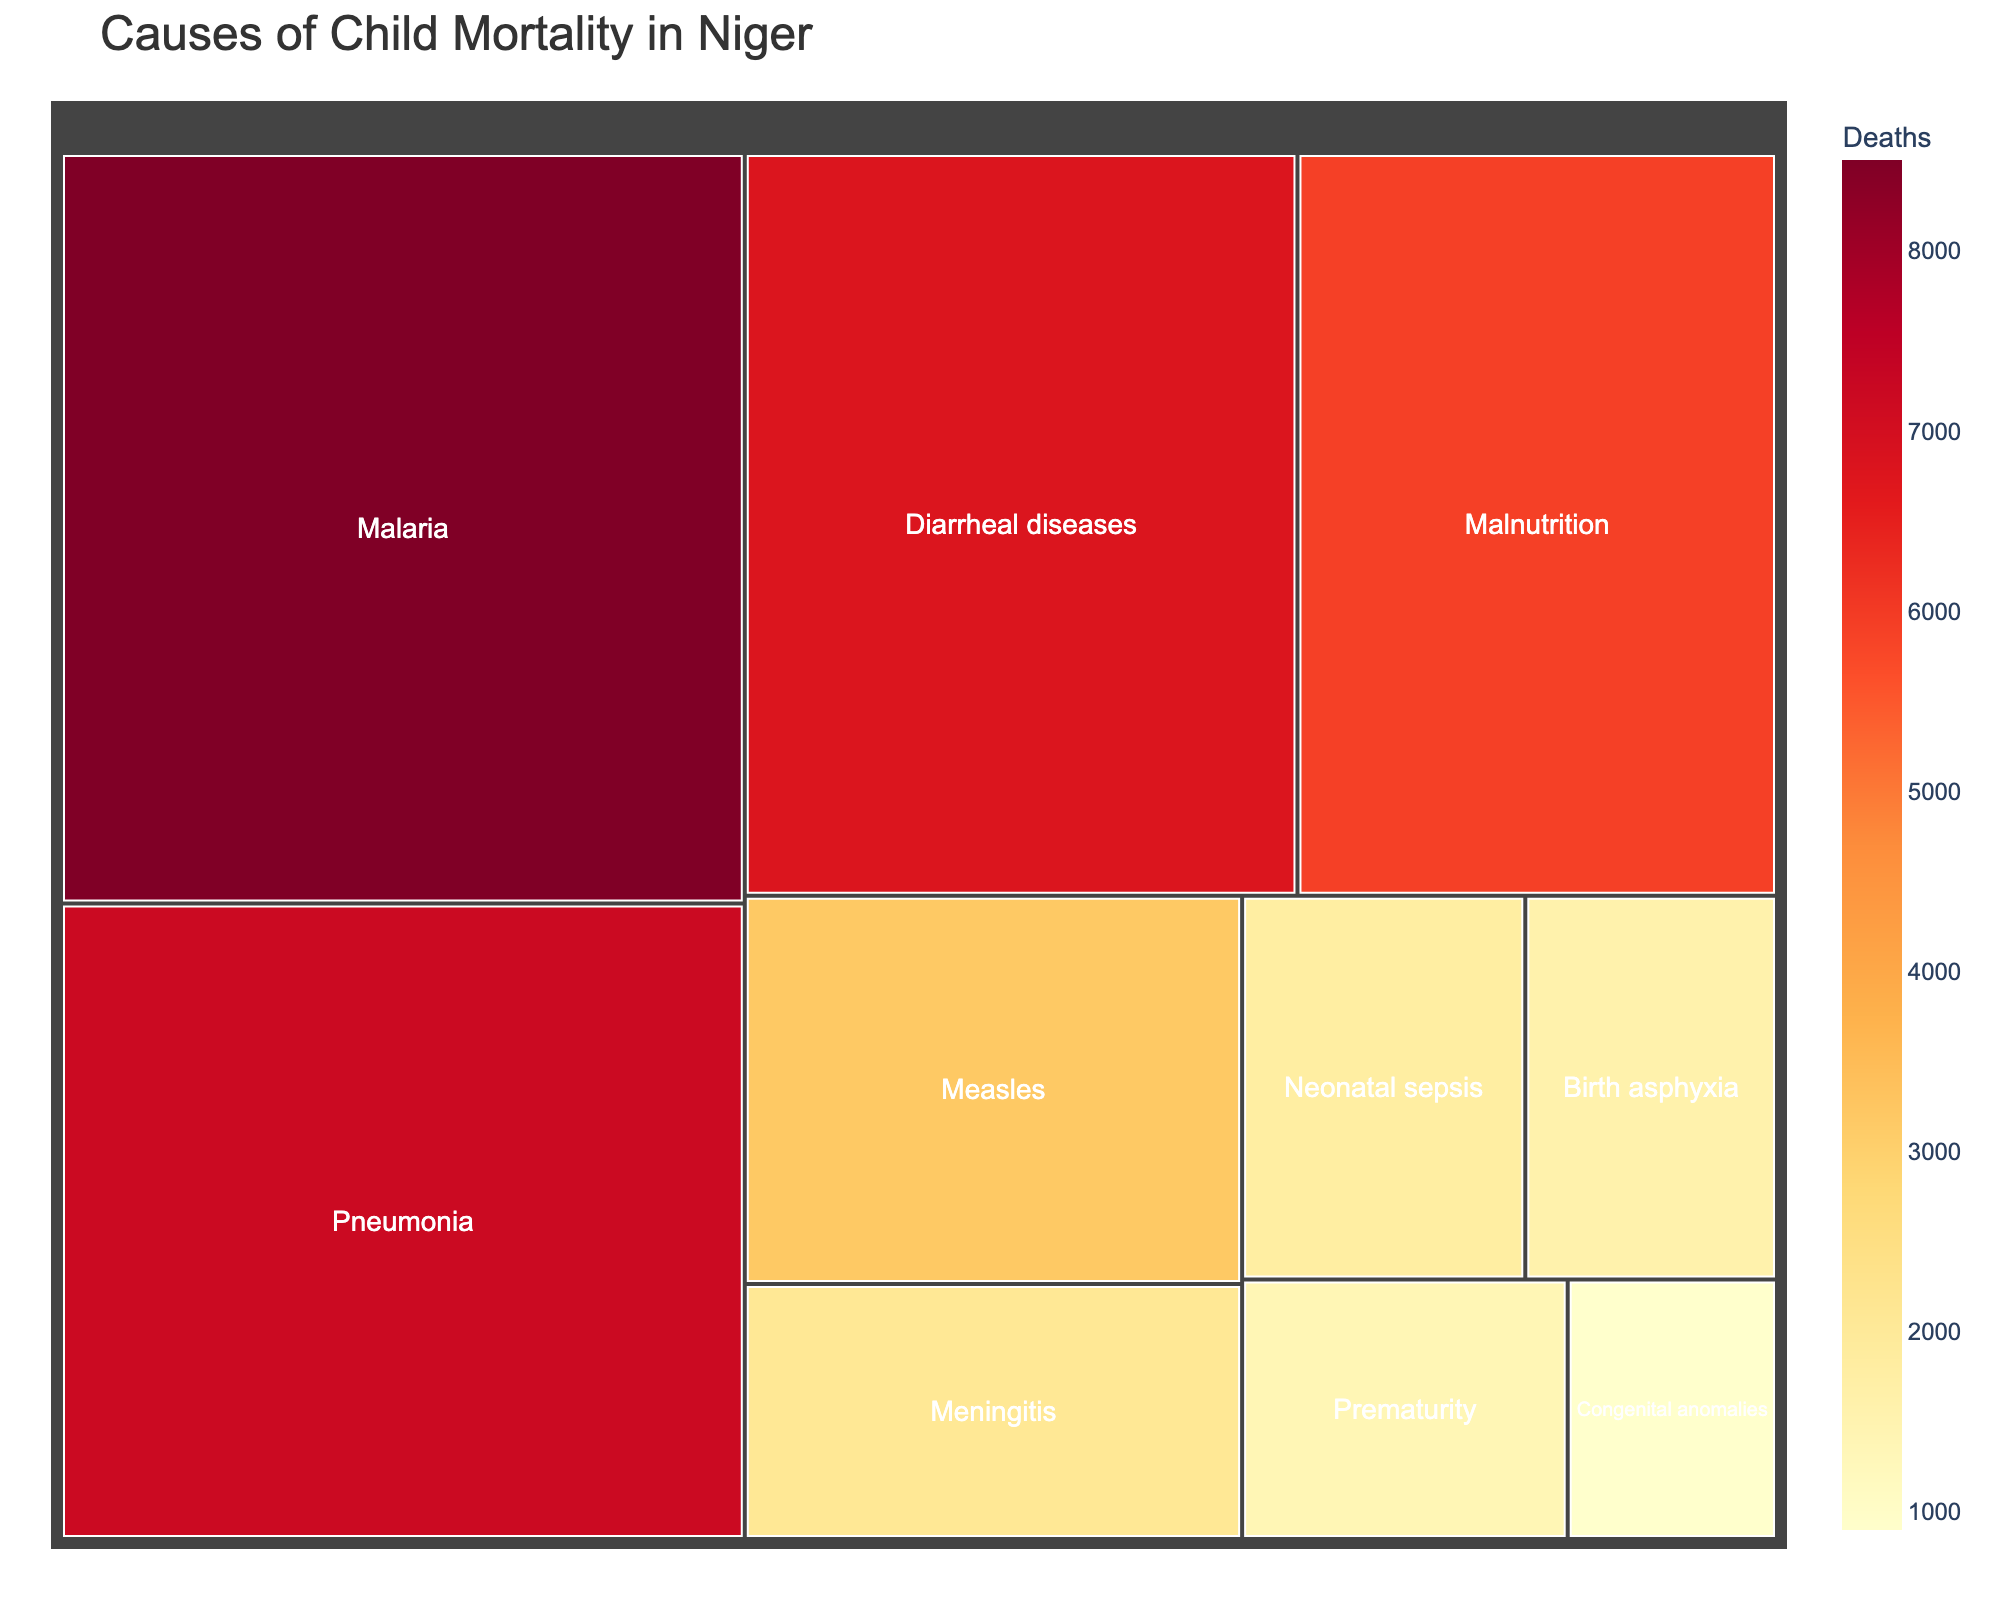What is the title of the treemap? The title is located at the top of the figure and summarizes the main topic of the visualization.
Answer: Causes of Child Mortality in Niger Which disease is responsible for the highest number of deaths? The treemap shows different diseases with varying sizes of blocks. The largest block corresponds to the disease with the highest number of deaths.
Answer: Malaria How many deaths are caused by Pneumonia? The treemap has labeled blocks with the number of deaths. Locate the block for Pneumonia to find the number of deaths.
Answer: 7200 Which disease has fewer deaths, Measles or Meningitis? Compare the blocks labeled Measles and Meningitis. The smaller block in terms of number of deaths indicates a lower value.
Answer: Meningitis What is the total number of deaths caused by Diarrheal diseases and Malnutrition? Add the deaths from Diarrheal diseases and Malnutrition blocks. Diarrheal diseases have 6800 deaths, and Malnutrition has 5900 deaths.
Answer: 12700 What is the color range used in the treemap? Observe the color gradient applied in the treemap which is from yellow to red to represent the number of deaths.
Answer: Yellow to red Rank the top three causes of child mortality in Niger as shown in the treemap. Based on the size and label of the blocks, identify the top three blocks with the highest number of deaths and rank them accordingly.
Answer: Malaria, Pneumonia, Diarrheal diseases Is Birth asphyxia responsible for more deaths than Neonatal sepsis? Compare the blocks of Birth asphyxia and Neonatal sepsis. The larger block indicates a higher number of deaths.
Answer: No What percentage of deaths are caused by Congenital anomalies relative to the total deaths shown in the treemap? Sum up the total number of deaths from all blocks, then divide the number of deaths caused by Congenital anomalies by this total and multiply by 100 to get the percentage.
Answer: 2.9% Which condition has the least number of deaths and how many? Find the smallest block in the treemap, which indicates the condition with the least number of deaths, and read the value.
Answer: Congenital anomalies, 900 